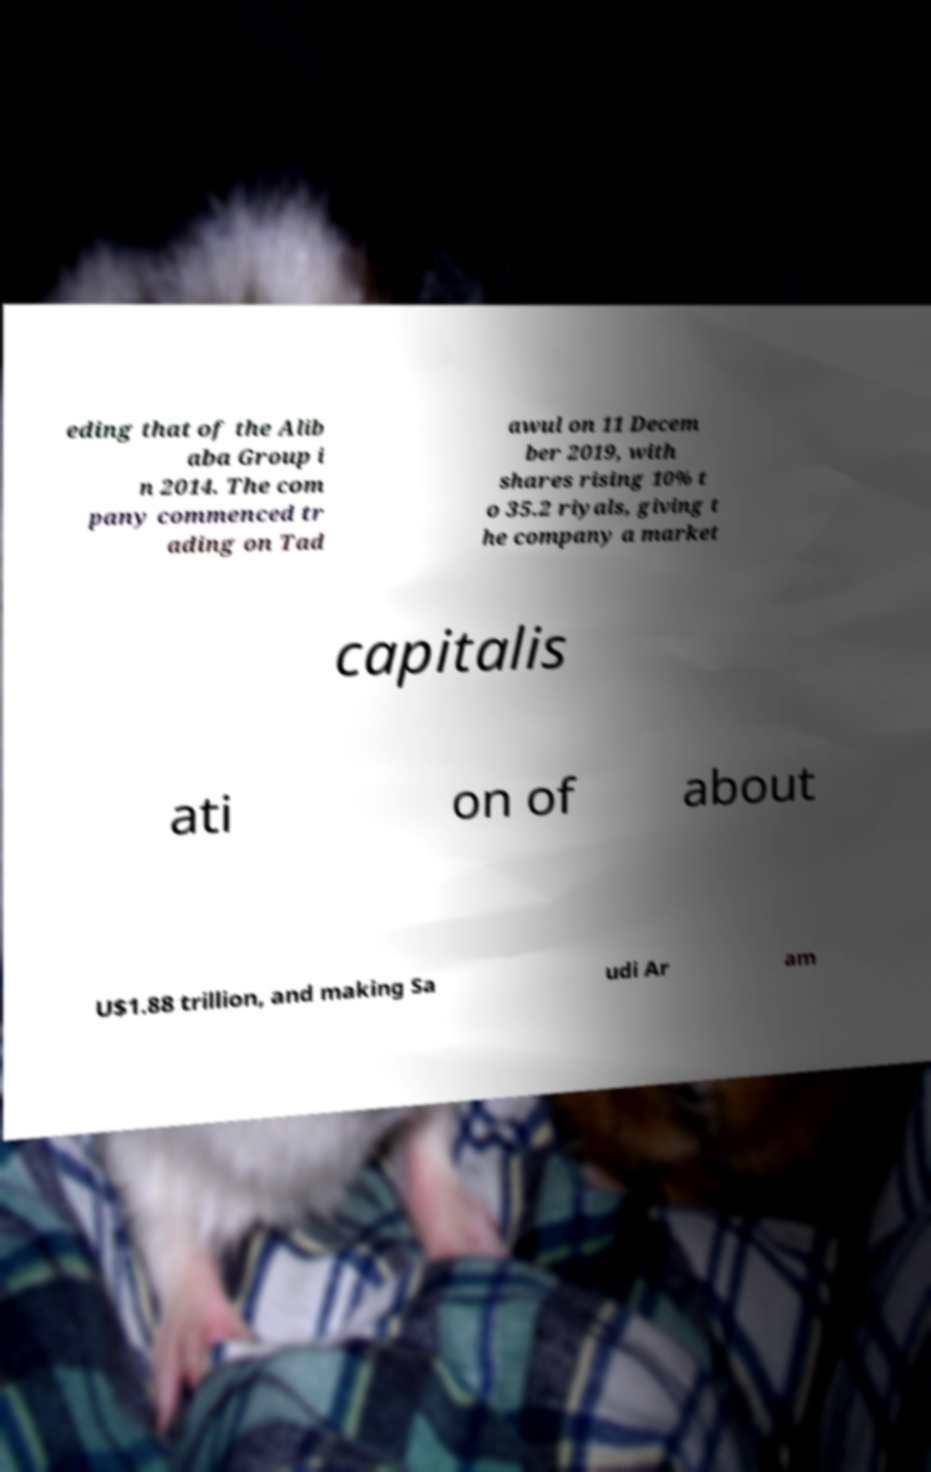Can you read and provide the text displayed in the image?This photo seems to have some interesting text. Can you extract and type it out for me? eding that of the Alib aba Group i n 2014. The com pany commenced tr ading on Tad awul on 11 Decem ber 2019, with shares rising 10% t o 35.2 riyals, giving t he company a market capitalis ati on of about U$1.88 trillion, and making Sa udi Ar am 